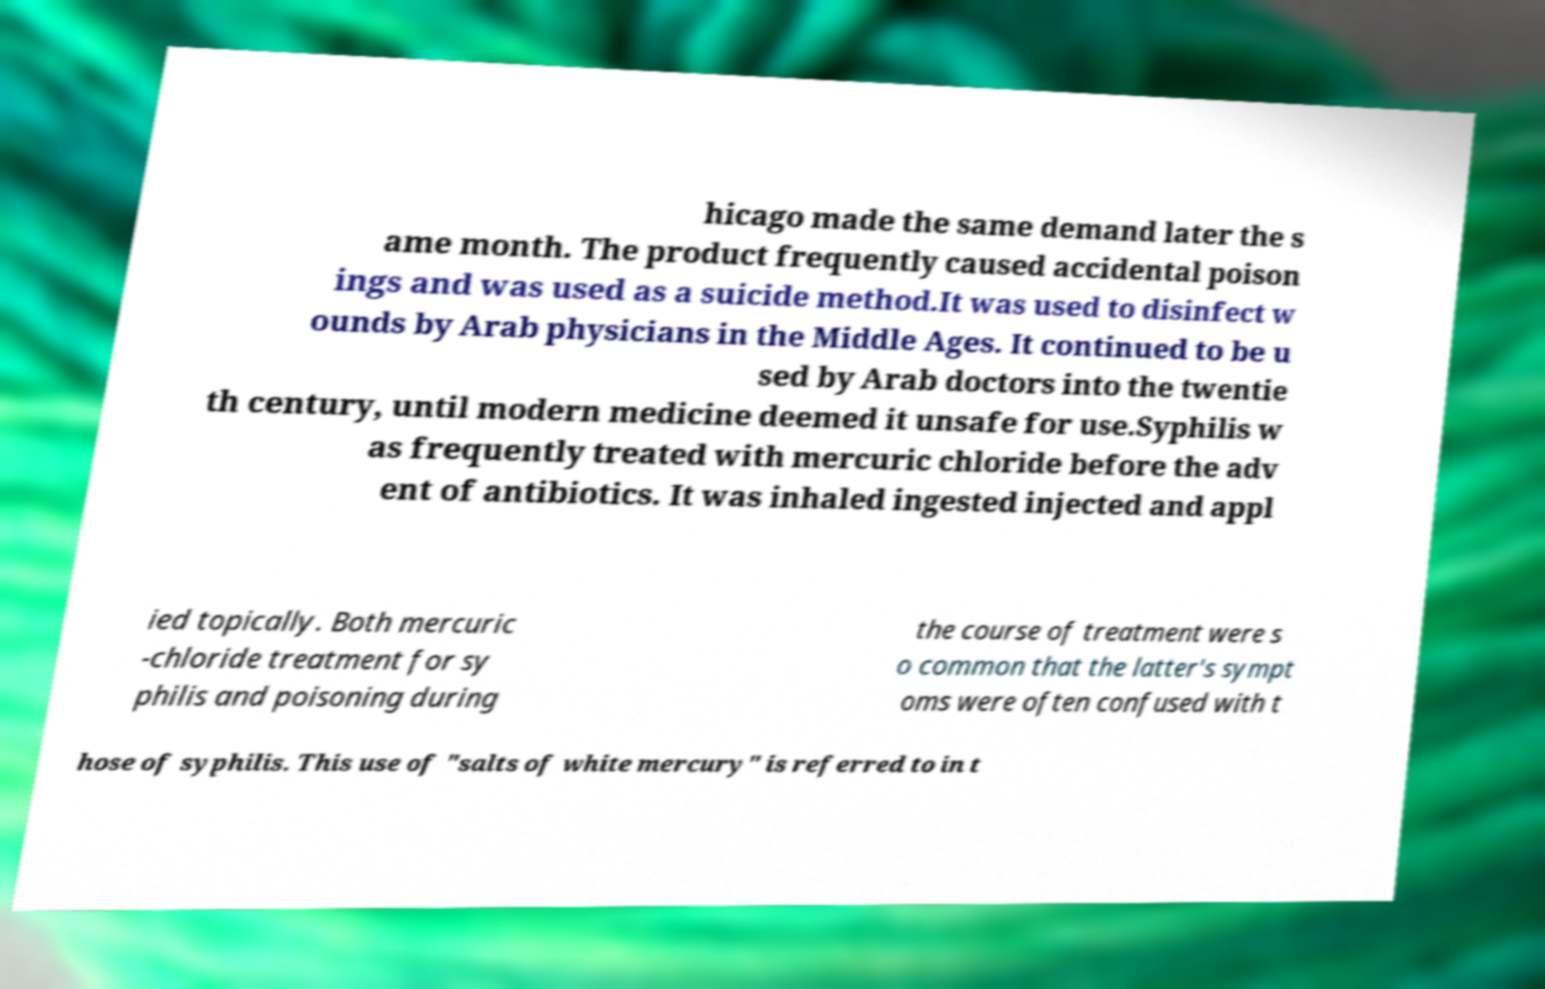Can you accurately transcribe the text from the provided image for me? hicago made the same demand later the s ame month. The product frequently caused accidental poison ings and was used as a suicide method.It was used to disinfect w ounds by Arab physicians in the Middle Ages. It continued to be u sed by Arab doctors into the twentie th century, until modern medicine deemed it unsafe for use.Syphilis w as frequently treated with mercuric chloride before the adv ent of antibiotics. It was inhaled ingested injected and appl ied topically. Both mercuric -chloride treatment for sy philis and poisoning during the course of treatment were s o common that the latter's sympt oms were often confused with t hose of syphilis. This use of "salts of white mercury" is referred to in t 